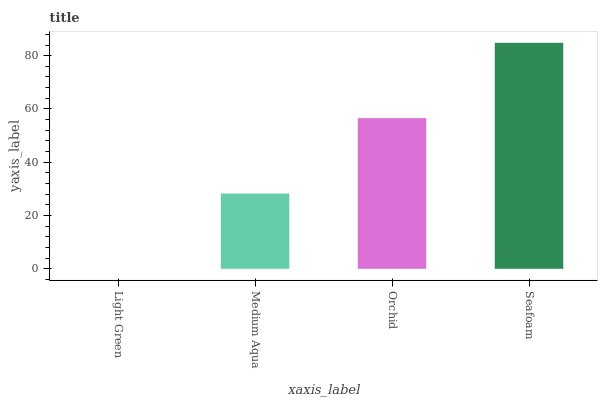Is Light Green the minimum?
Answer yes or no. Yes. Is Seafoam the maximum?
Answer yes or no. Yes. Is Medium Aqua the minimum?
Answer yes or no. No. Is Medium Aqua the maximum?
Answer yes or no. No. Is Medium Aqua greater than Light Green?
Answer yes or no. Yes. Is Light Green less than Medium Aqua?
Answer yes or no. Yes. Is Light Green greater than Medium Aqua?
Answer yes or no. No. Is Medium Aqua less than Light Green?
Answer yes or no. No. Is Orchid the high median?
Answer yes or no. Yes. Is Medium Aqua the low median?
Answer yes or no. Yes. Is Light Green the high median?
Answer yes or no. No. Is Orchid the low median?
Answer yes or no. No. 